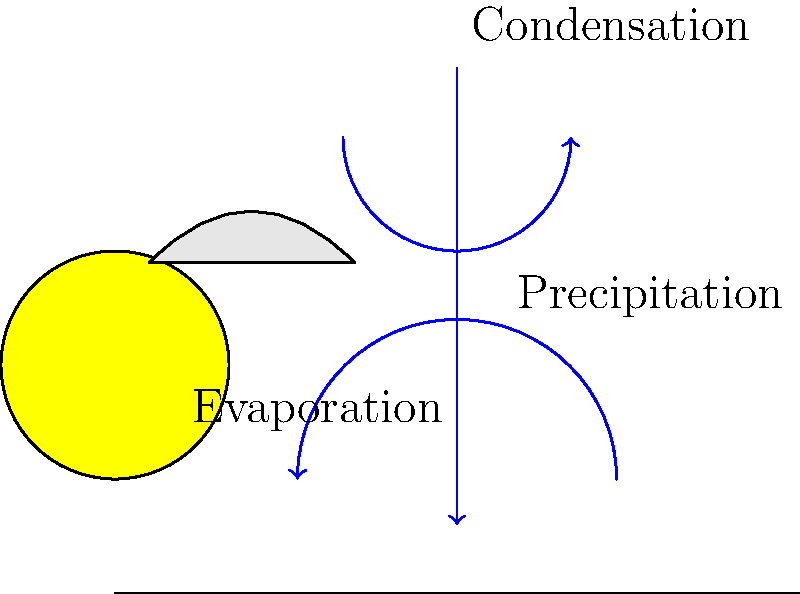In the water cycle diagram above, which process is responsible for the formation of clouds? To answer this question, let's go through the water cycle processes shown in the diagram:

1. Evaporation: This process occurs when water on the Earth's surface (e.g., oceans, lakes) turns into water vapor due to heat from the sun. In the diagram, this is represented by the upward arrow labeled "Evaporation."

2. Condensation: As water vapor rises into the cooler atmosphere, it cools and condenses into tiny water droplets. These droplets form clouds. In the diagram, this process is shown by the curved arrow near the cloud, labeled "Condensation."

3. Precipitation: When the water droplets in clouds become too heavy, they fall back to Earth as rain, snow, or other forms of precipitation. This is represented by the downward arrow labeled "Precipitation."

The question asks specifically about cloud formation. Among these processes, condensation is directly responsible for the formation of clouds. As water vapor rises and cools, it condenses into tiny water droplets or ice crystals, which collectively form visible clouds.

Therefore, the process responsible for the formation of clouds in the water cycle is condensation.
Answer: Condensation 